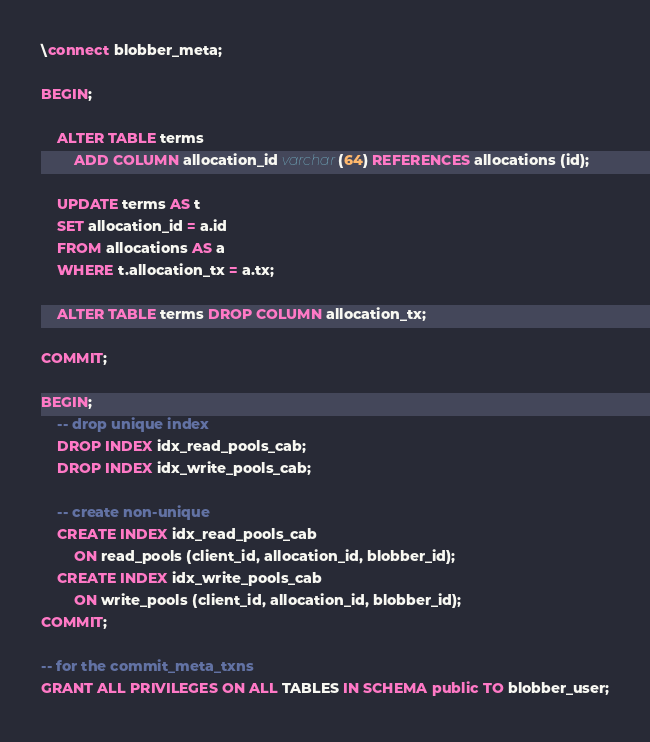<code> <loc_0><loc_0><loc_500><loc_500><_SQL_>\connect blobber_meta;

BEGIN;

    ALTER TABLE terms
        ADD COLUMN allocation_id varchar(64) REFERENCES allocations (id);

    UPDATE terms AS t
    SET allocation_id = a.id
    FROM allocations AS a
    WHERE t.allocation_tx = a.tx;

    ALTER TABLE terms DROP COLUMN allocation_tx;

COMMIT;

BEGIN;
    -- drop unique index
    DROP INDEX idx_read_pools_cab;
    DROP INDEX idx_write_pools_cab;

    -- create non-unique
    CREATE INDEX idx_read_pools_cab
        ON read_pools (client_id, allocation_id, blobber_id);
    CREATE INDEX idx_write_pools_cab
        ON write_pools (client_id, allocation_id, blobber_id);
COMMIT;

-- for the commit_meta_txns
GRANT ALL PRIVILEGES ON ALL TABLES IN SCHEMA public TO blobber_user;
</code> 